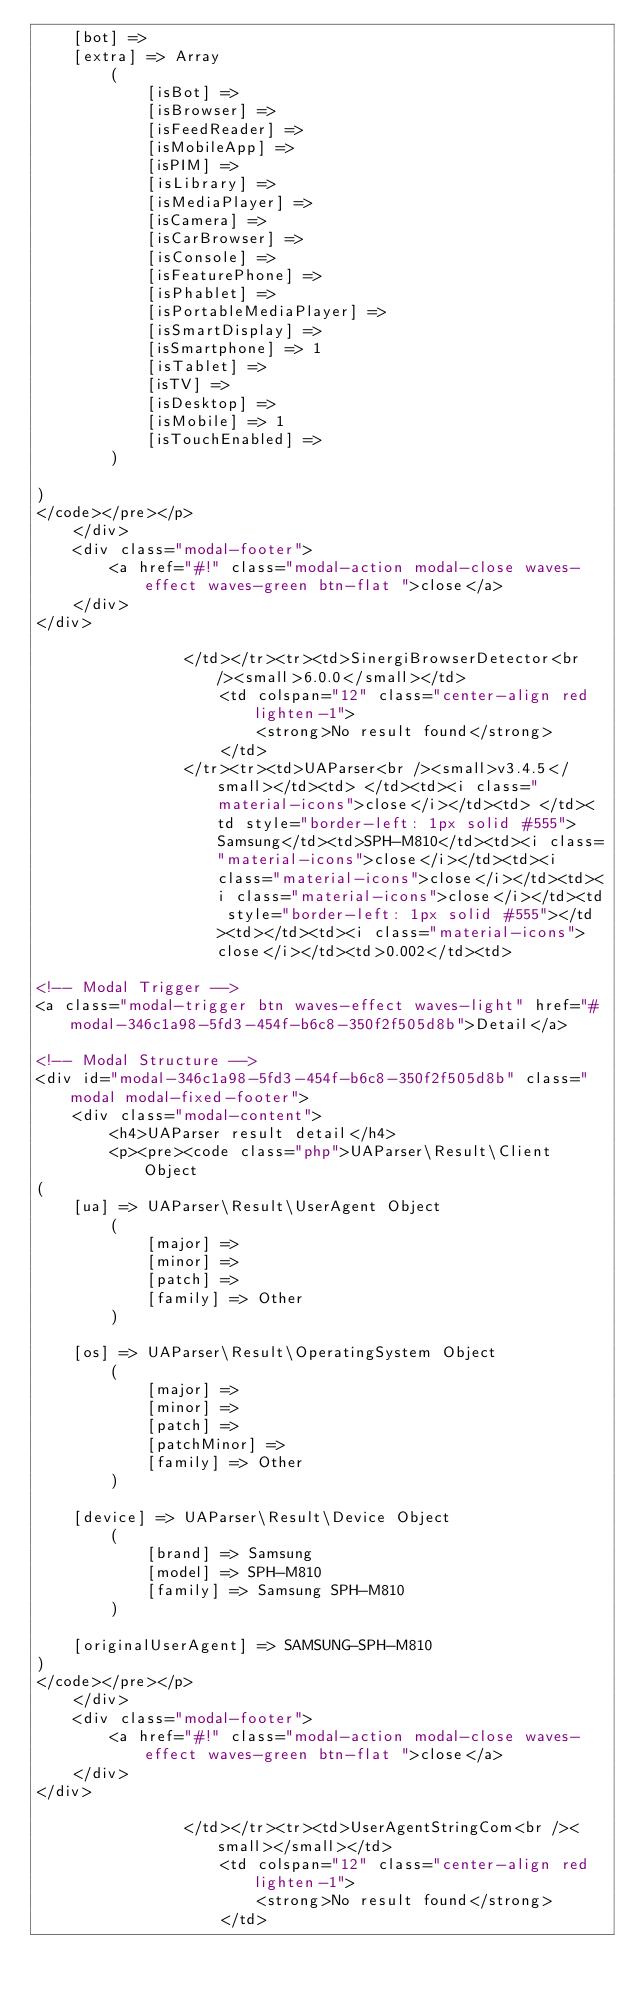Convert code to text. <code><loc_0><loc_0><loc_500><loc_500><_HTML_>    [bot] => 
    [extra] => Array
        (
            [isBot] => 
            [isBrowser] => 
            [isFeedReader] => 
            [isMobileApp] => 
            [isPIM] => 
            [isLibrary] => 
            [isMediaPlayer] => 
            [isCamera] => 
            [isCarBrowser] => 
            [isConsole] => 
            [isFeaturePhone] => 
            [isPhablet] => 
            [isPortableMediaPlayer] => 
            [isSmartDisplay] => 
            [isSmartphone] => 1
            [isTablet] => 
            [isTV] => 
            [isDesktop] => 
            [isMobile] => 1
            [isTouchEnabled] => 
        )

)
</code></pre></p>
    </div>
    <div class="modal-footer">
        <a href="#!" class="modal-action modal-close waves-effect waves-green btn-flat ">close</a>
    </div>
</div>
                
                </td></tr><tr><td>SinergiBrowserDetector<br /><small>6.0.0</small></td>
                    <td colspan="12" class="center-align red lighten-1">
                        <strong>No result found</strong>
                    </td>
                </tr><tr><td>UAParser<br /><small>v3.4.5</small></td><td> </td><td><i class="material-icons">close</i></td><td> </td><td style="border-left: 1px solid #555">Samsung</td><td>SPH-M810</td><td><i class="material-icons">close</i></td><td><i class="material-icons">close</i></td><td><i class="material-icons">close</i></td><td style="border-left: 1px solid #555"></td><td></td><td><i class="material-icons">close</i></td><td>0.002</td><td>
                
<!-- Modal Trigger -->
<a class="modal-trigger btn waves-effect waves-light" href="#modal-346c1a98-5fd3-454f-b6c8-350f2f505d8b">Detail</a>

<!-- Modal Structure -->
<div id="modal-346c1a98-5fd3-454f-b6c8-350f2f505d8b" class="modal modal-fixed-footer">
    <div class="modal-content">
        <h4>UAParser result detail</h4>
        <p><pre><code class="php">UAParser\Result\Client Object
(
    [ua] => UAParser\Result\UserAgent Object
        (
            [major] => 
            [minor] => 
            [patch] => 
            [family] => Other
        )

    [os] => UAParser\Result\OperatingSystem Object
        (
            [major] => 
            [minor] => 
            [patch] => 
            [patchMinor] => 
            [family] => Other
        )

    [device] => UAParser\Result\Device Object
        (
            [brand] => Samsung
            [model] => SPH-M810
            [family] => Samsung SPH-M810
        )

    [originalUserAgent] => SAMSUNG-SPH-M810
)
</code></pre></p>
    </div>
    <div class="modal-footer">
        <a href="#!" class="modal-action modal-close waves-effect waves-green btn-flat ">close</a>
    </div>
</div>
                
                </td></tr><tr><td>UserAgentStringCom<br /><small></small></td>
                    <td colspan="12" class="center-align red lighten-1">
                        <strong>No result found</strong>
                    </td></code> 